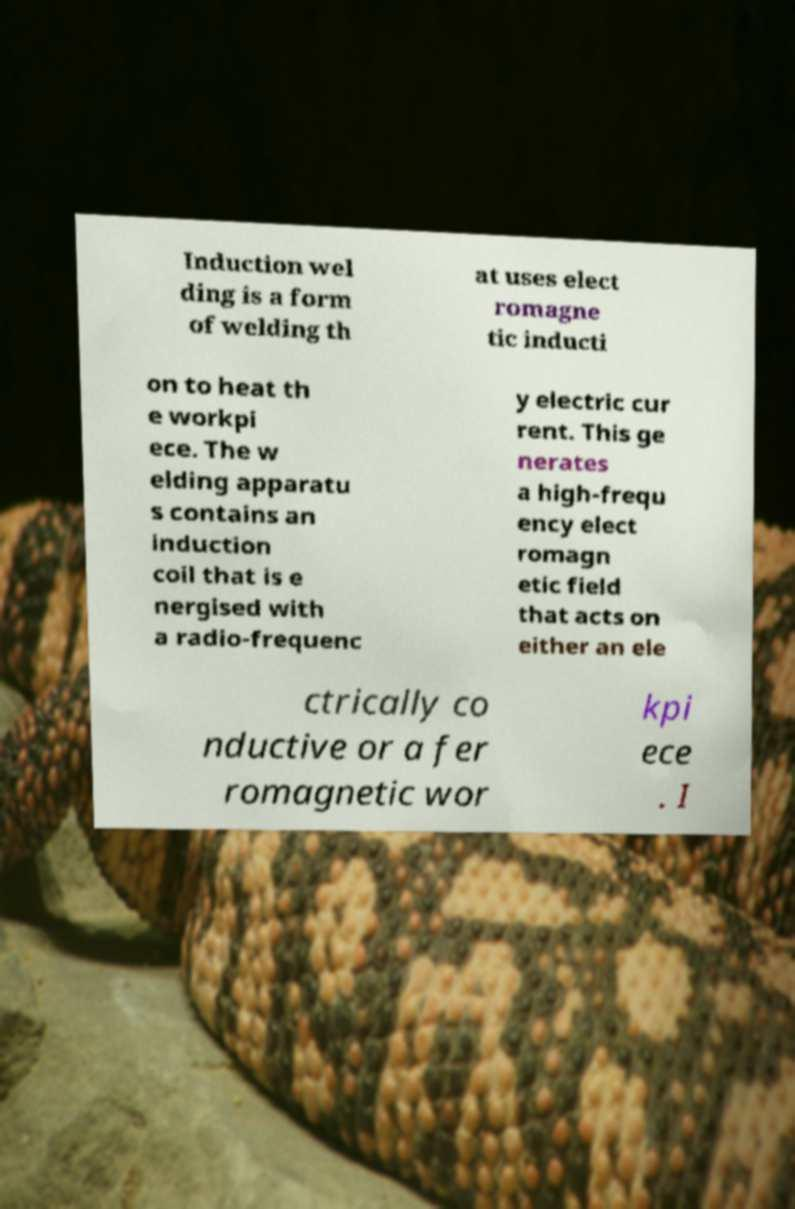Could you assist in decoding the text presented in this image and type it out clearly? Induction wel ding is a form of welding th at uses elect romagne tic inducti on to heat th e workpi ece. The w elding apparatu s contains an induction coil that is e nergised with a radio-frequenc y electric cur rent. This ge nerates a high-frequ ency elect romagn etic field that acts on either an ele ctrically co nductive or a fer romagnetic wor kpi ece . I 